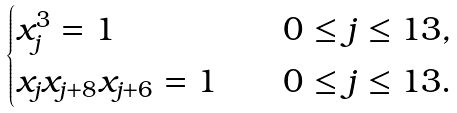<formula> <loc_0><loc_0><loc_500><loc_500>\begin{cases} x _ { j } ^ { 3 } = 1 \quad & 0 \leq j \leq 1 3 , \\ x _ { j } x _ { j + 8 } x _ { j + 6 } = 1 \quad & 0 \leq j \leq 1 3 . \end{cases}</formula> 